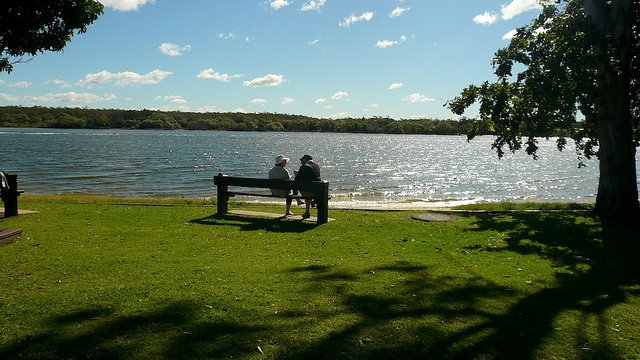Describe the objects in this image and their specific colors. I can see bench in black, gray, and darkgray tones, people in black, gray, darkgray, and darkgreen tones, bench in black, gray, darkgray, and darkgreen tones, and people in black, gray, darkgray, and lightgray tones in this image. 